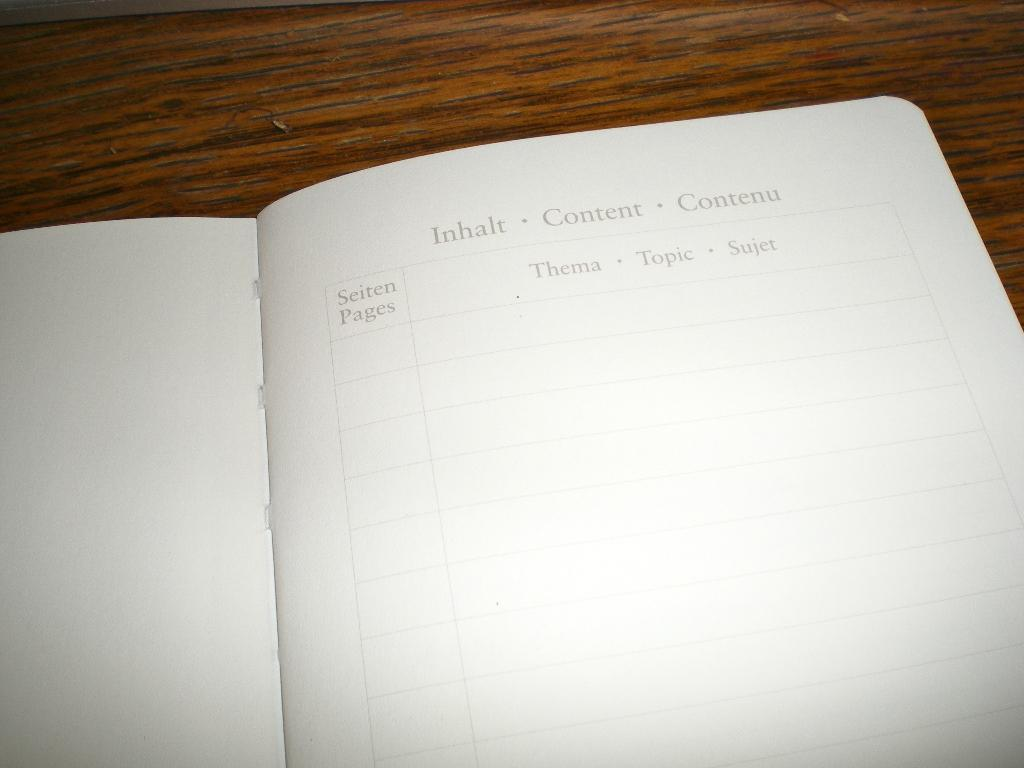Provide a one-sentence caption for the provided image. An open notebook with Inhalt Content Contenu as the heading. 